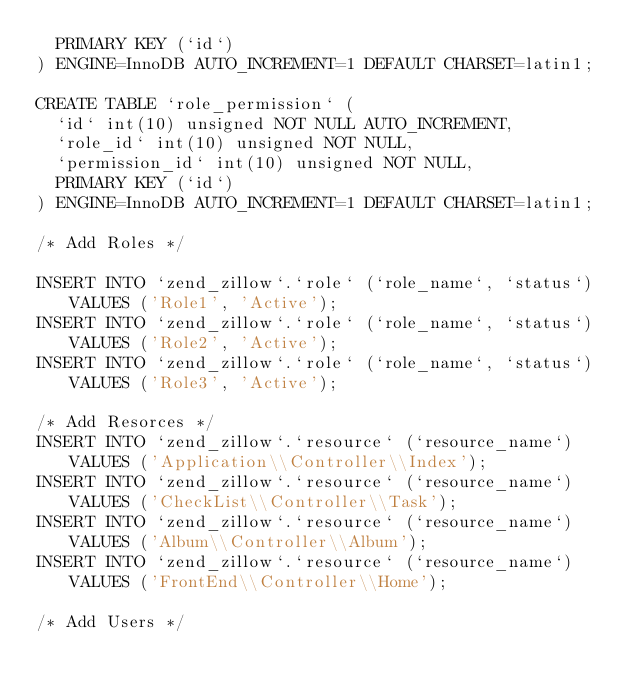Convert code to text. <code><loc_0><loc_0><loc_500><loc_500><_SQL_>  PRIMARY KEY (`id`)
) ENGINE=InnoDB AUTO_INCREMENT=1 DEFAULT CHARSET=latin1;

CREATE TABLE `role_permission` (
  `id` int(10) unsigned NOT NULL AUTO_INCREMENT,
  `role_id` int(10) unsigned NOT NULL,
  `permission_id` int(10) unsigned NOT NULL,
  PRIMARY KEY (`id`)
) ENGINE=InnoDB AUTO_INCREMENT=1 DEFAULT CHARSET=latin1;

/* Add Roles */

INSERT INTO `zend_zillow`.`role` (`role_name`, `status`) VALUES ('Role1', 'Active');
INSERT INTO `zend_zillow`.`role` (`role_name`, `status`) VALUES ('Role2', 'Active');
INSERT INTO `zend_zillow`.`role` (`role_name`, `status`) VALUES ('Role3', 'Active');

/* Add Resorces */
INSERT INTO `zend_zillow`.`resource` (`resource_name`) VALUES ('Application\\Controller\\Index');
INSERT INTO `zend_zillow`.`resource` (`resource_name`) VALUES ('CheckList\\Controller\\Task');
INSERT INTO `zend_zillow`.`resource` (`resource_name`) VALUES ('Album\\Controller\\Album');
INSERT INTO `zend_zillow`.`resource` (`resource_name`) VALUES ('FrontEnd\\Controller\\Home');

/* Add Users */</code> 